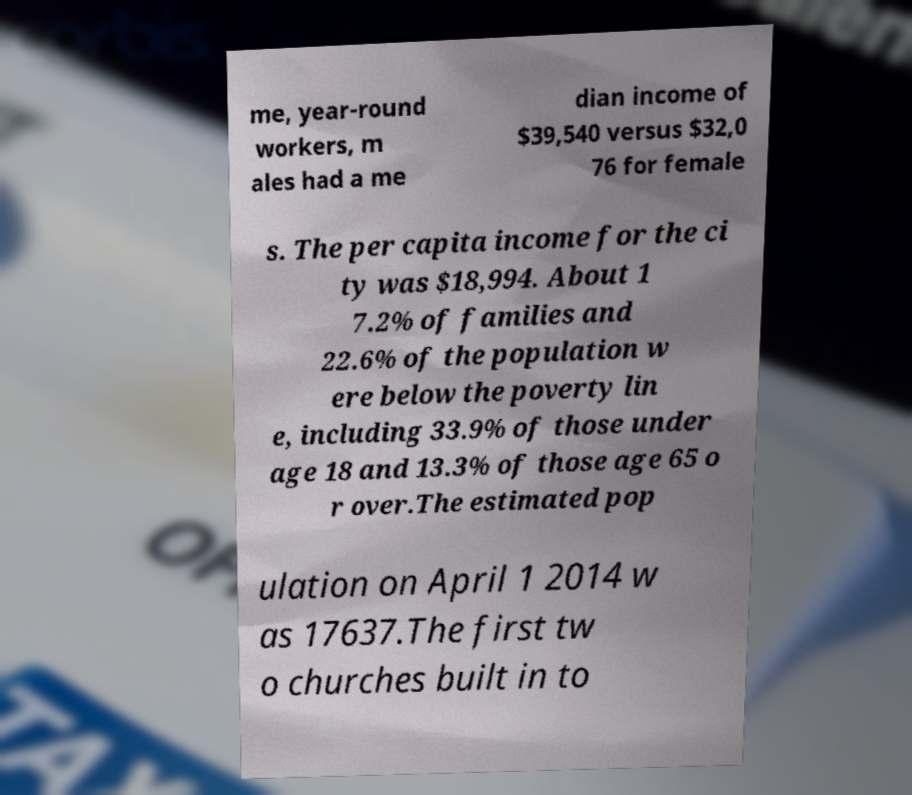For documentation purposes, I need the text within this image transcribed. Could you provide that? me, year-round workers, m ales had a me dian income of $39,540 versus $32,0 76 for female s. The per capita income for the ci ty was $18,994. About 1 7.2% of families and 22.6% of the population w ere below the poverty lin e, including 33.9% of those under age 18 and 13.3% of those age 65 o r over.The estimated pop ulation on April 1 2014 w as 17637.The first tw o churches built in to 